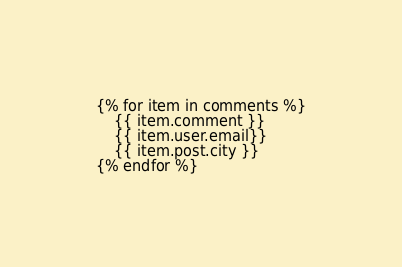Convert code to text. <code><loc_0><loc_0><loc_500><loc_500><_HTML_>{% for item in comments %}
	{{ item.comment }}
	{{ item.user.email}}
	{{ item.post.city }}
{% endfor %}
</code> 